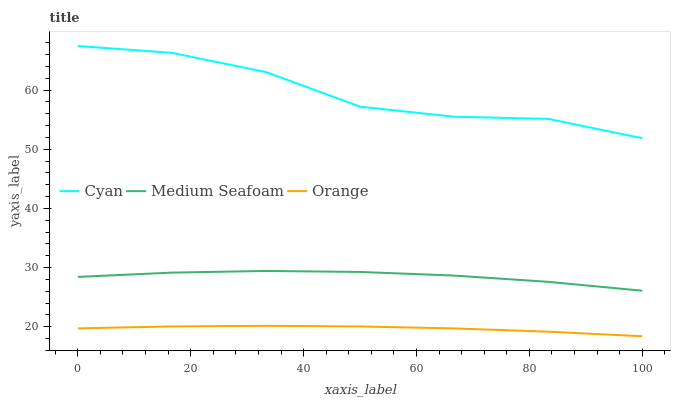Does Orange have the minimum area under the curve?
Answer yes or no. Yes. Does Cyan have the maximum area under the curve?
Answer yes or no. Yes. Does Medium Seafoam have the minimum area under the curve?
Answer yes or no. No. Does Medium Seafoam have the maximum area under the curve?
Answer yes or no. No. Is Orange the smoothest?
Answer yes or no. Yes. Is Cyan the roughest?
Answer yes or no. Yes. Is Medium Seafoam the smoothest?
Answer yes or no. No. Is Medium Seafoam the roughest?
Answer yes or no. No. Does Orange have the lowest value?
Answer yes or no. Yes. Does Medium Seafoam have the lowest value?
Answer yes or no. No. Does Cyan have the highest value?
Answer yes or no. Yes. Does Medium Seafoam have the highest value?
Answer yes or no. No. Is Medium Seafoam less than Cyan?
Answer yes or no. Yes. Is Medium Seafoam greater than Orange?
Answer yes or no. Yes. Does Medium Seafoam intersect Cyan?
Answer yes or no. No. 